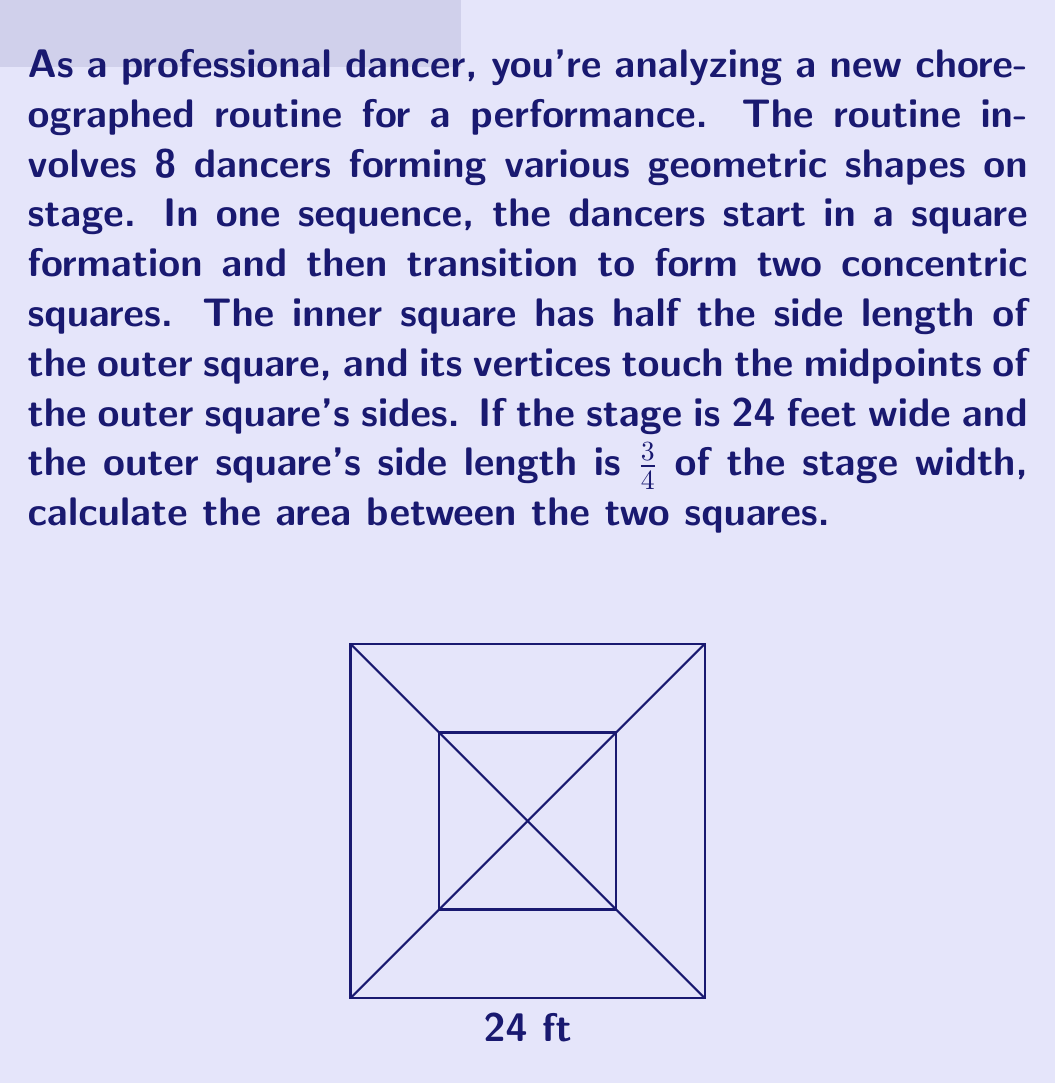Could you help me with this problem? Let's approach this step-by-step:

1) First, we need to determine the side length of the outer square:
   Stage width = 24 feet
   Outer square side length = 3/4 * 24 = 18 feet

2) The inner square has half the side length of the outer square:
   Inner square side length = 18/2 = 9 feet

3) Now, we need to calculate the areas of both squares:
   Outer square area: $A_o = 18^2 = 324$ sq ft
   Inner square area: $A_i = 9^2 = 81$ sq ft

4) The area between the squares is the difference between these areas:
   $A_{between} = A_o - A_i = 324 - 81 = 243$ sq ft

Therefore, the area between the two squares is 243 square feet.
Answer: 243 sq ft 